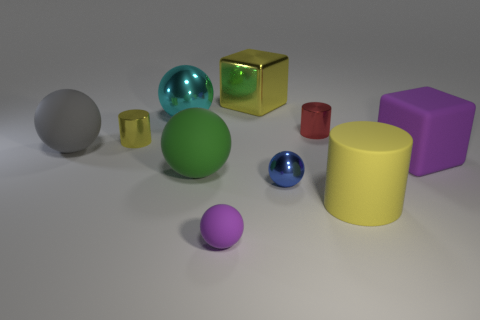There is a red shiny cylinder behind the metal thing that is in front of the big purple matte object; is there a big gray object that is behind it?
Offer a terse response. No. There is a purple rubber thing that is the same size as the yellow metallic cylinder; what is its shape?
Give a very brief answer. Sphere. How many other things are the same color as the tiny metallic sphere?
Provide a succinct answer. 0. What is the gray ball made of?
Provide a succinct answer. Rubber. How many other objects are there of the same material as the gray sphere?
Offer a very short reply. 4. There is a matte object that is in front of the green sphere and behind the small purple rubber thing; what size is it?
Offer a terse response. Large. What is the shape of the rubber object on the left side of the yellow cylinder on the left side of the large rubber cylinder?
Provide a succinct answer. Sphere. Are there the same number of tiny yellow cylinders in front of the tiny matte thing and brown things?
Your response must be concise. Yes. There is a large cylinder; does it have the same color as the small thing that is on the left side of the small purple rubber thing?
Offer a very short reply. Yes. There is a tiny object that is on the right side of the large shiny block and in front of the gray rubber sphere; what color is it?
Offer a terse response. Blue. 